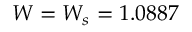Convert formula to latex. <formula><loc_0><loc_0><loc_500><loc_500>W = W _ { s } = 1 . 0 8 8 7</formula> 